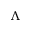<formula> <loc_0><loc_0><loc_500><loc_500>\Lambda</formula> 